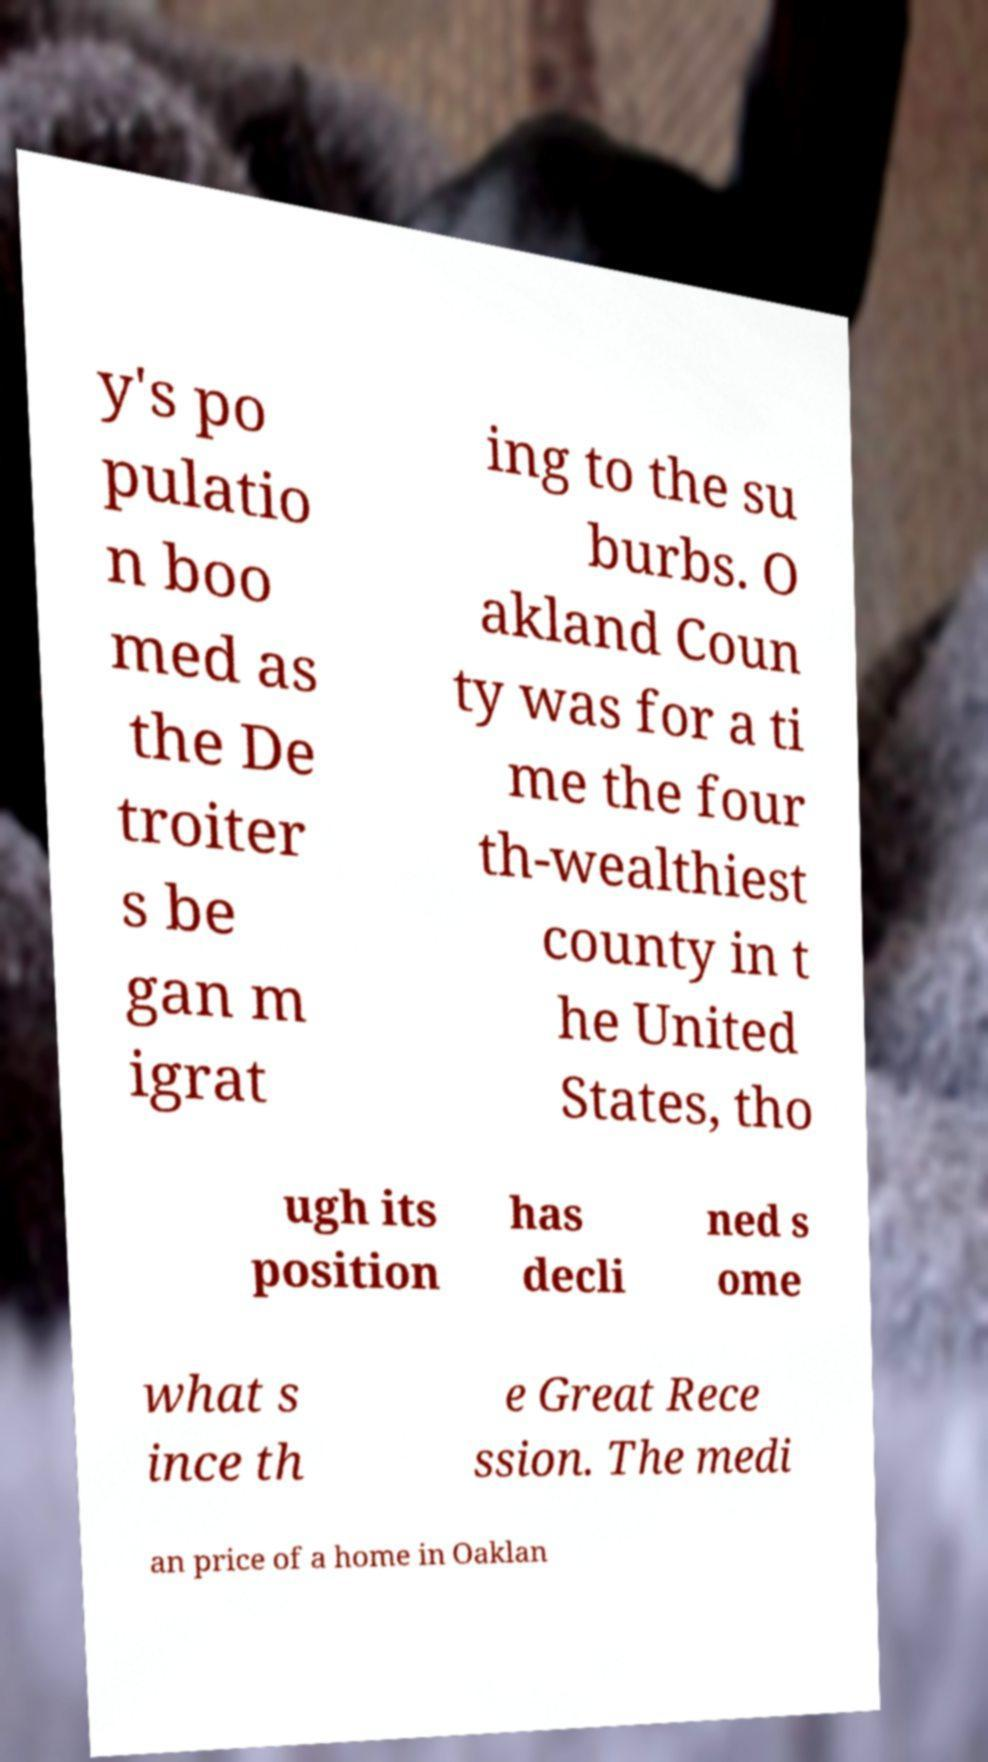Could you assist in decoding the text presented in this image and type it out clearly? y's po pulatio n boo med as the De troiter s be gan m igrat ing to the su burbs. O akland Coun ty was for a ti me the four th-wealthiest county in t he United States, tho ugh its position has decli ned s ome what s ince th e Great Rece ssion. The medi an price of a home in Oaklan 